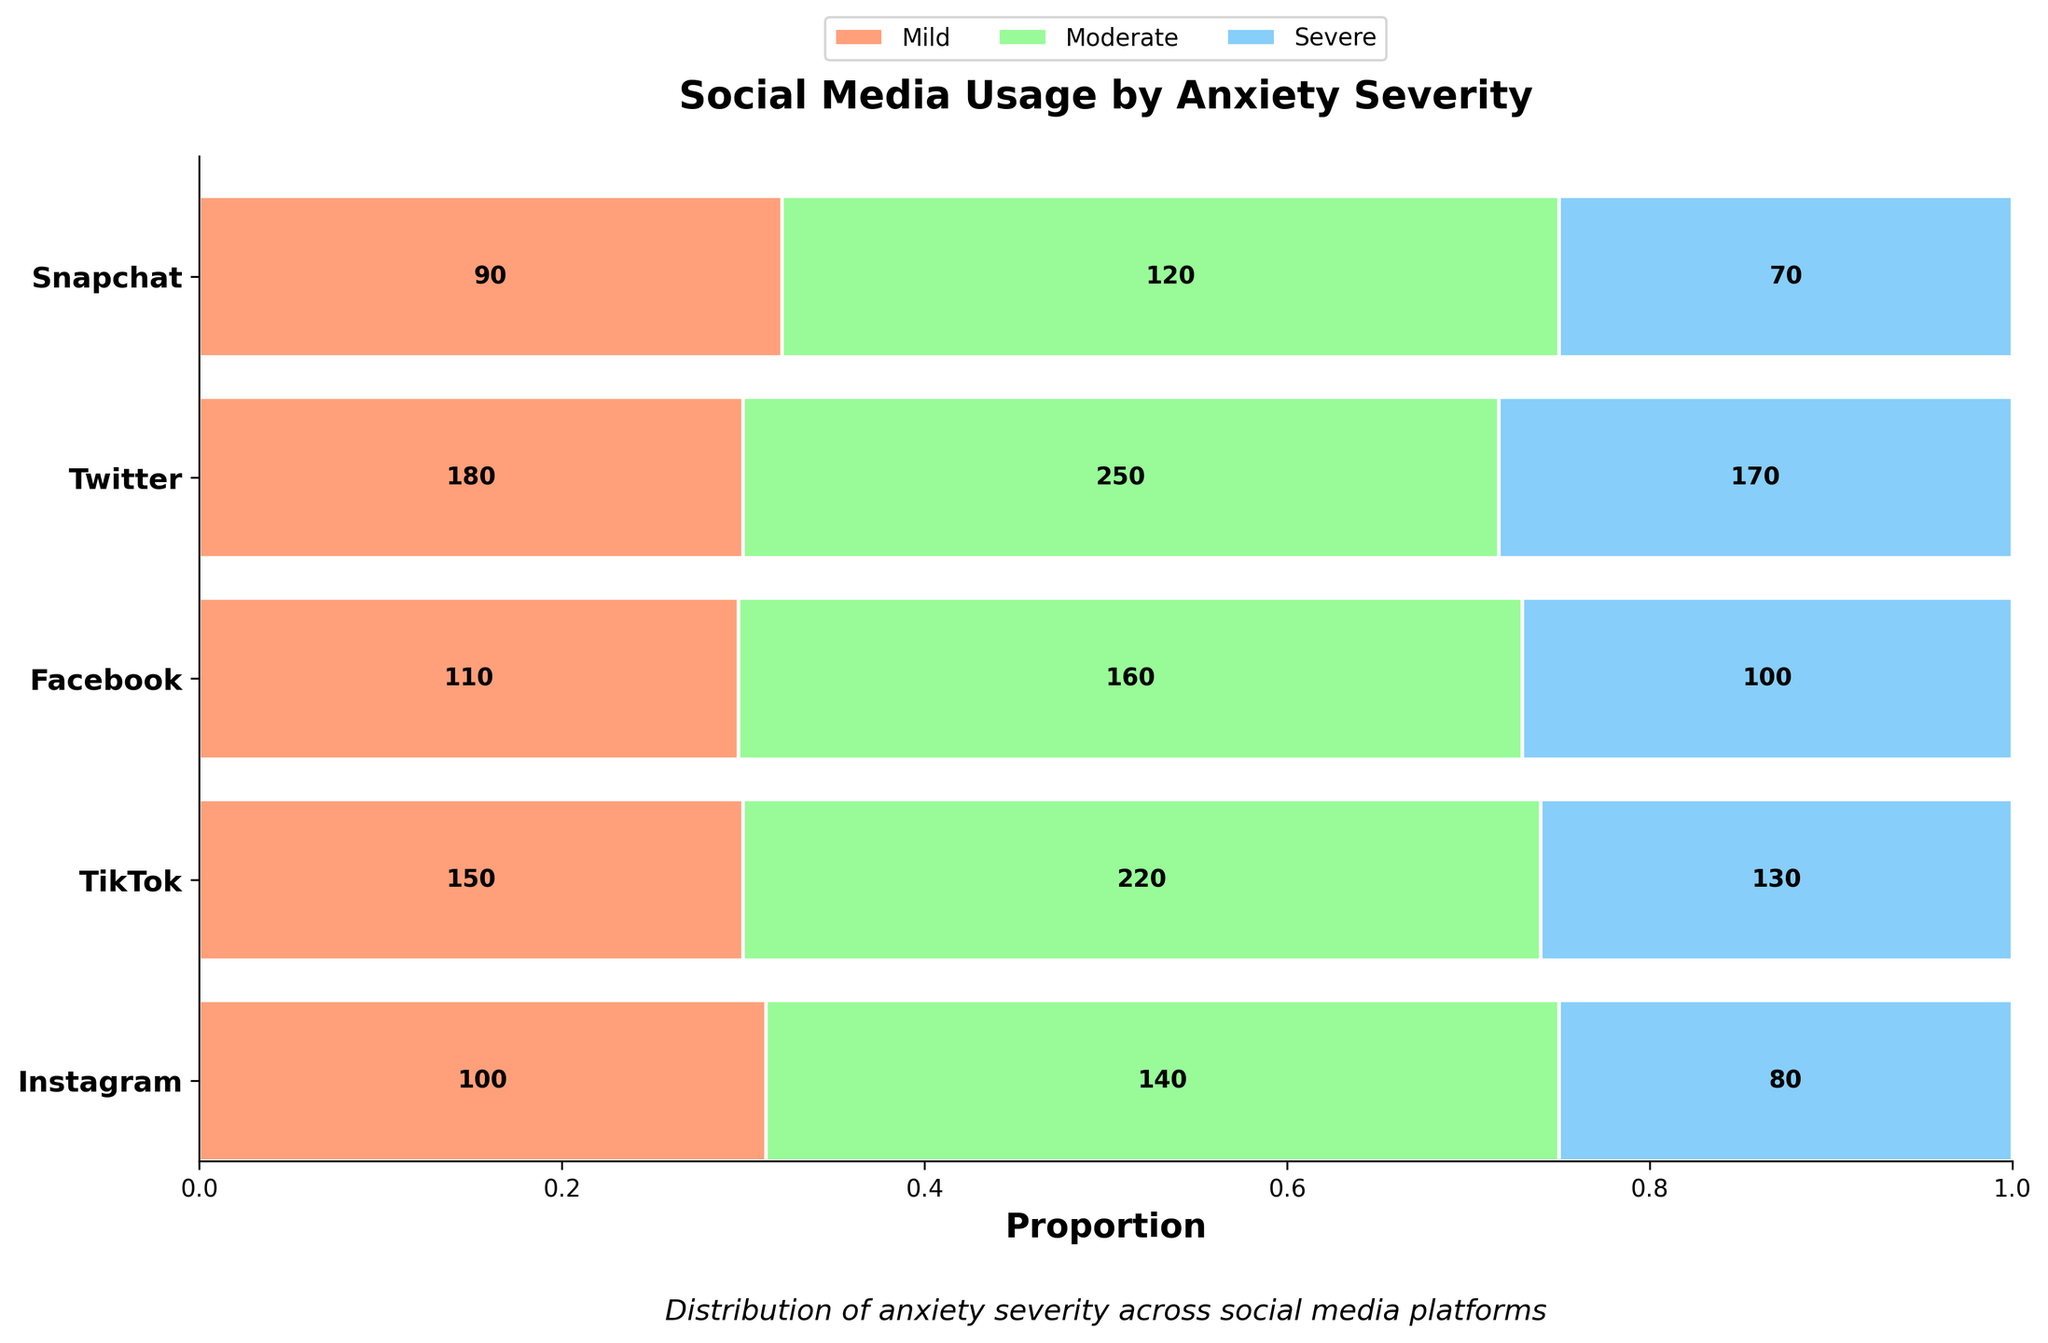Which platform has the highest count for severe anxiety cases? To determine this, look at the sections labeled "Severe" and compare the heights of the bars for each platform. The platform with the highest segment among these is TikTok with 170 cases.
Answer: TikTok What is the total number of young adults with moderate anxiety using Snapchat and Facebook combined? To find this, add the counts for moderate anxiety for Snapchat and Facebook. Snapchat has 160 cases, and Facebook has 140. So, the total is 160 + 140 = 300.
Answer: 300 Which platform has the smallest proportion of mild anxiety cases? To find the platform with the smallest proportion of mild anxiety, compare the widths of the mild anxiety segments across all platforms. Twitter has the narrowest segment for mild anxiety.
Answer: Twitter How does the number of moderate anxiety cases compare between Instagram and TikTok? Compare the counts of moderate anxiety cases for Instagram (220) and TikTok (250). TikTok has more cases (250 > 220).
Answer: TikTok has more Rank the platforms from highest to lowest based on severe anxiety cases. Rank the platforms by their counts for severe anxiety: TikTok (170), Instagram (130), Snapchat (100), Facebook (80), and Twitter (70). This ranking is based on the heights of the "Severe" segments.
Answer: TikTok, Instagram, Snapchat, Facebook, Twitter What proportion of Facebook users have moderate anxiety? Calculate the proportion by dividing the count of moderate anxiety cases on Facebook by the total number of Facebook users. The counts are: Mild (100), Moderate (140), Severe (80), totaling 320. The proportion is 140/320 = 0.4375.
Answer: 0.4375 Which social media platform has the most balanced distribution of anxiety severities? Assess the relative proportions of mild, moderate, and severe categories for each platform. Snapchat appears to have a more evenly distributed set of counts among the three categories, compared to other platforms.
Answer: Snapchat How many more severe anxiety cases are there on TikTok compared to Instagram? Subtract the severe anxiety cases of Instagram from TikTok. TikTok has 170 cases, Instagram has 130, so the difference is 170 - 130 = 40.
Answer: 40 Which social media platform has the highest proportion of moderate anxiety cases out of total severe and moderate cases combined? Calculate for each platform the ratio of moderate cases to the combined moderate and severe cases. Instagram: 220/(220+130) = 0.628. TikTok: 250/(250+170) = 0.595. Facebook: 140/(140+80) = 0.636. Twitter: 120/(120+70) = 0.63. Snapchat: 160/(160+100) = 0.615. Facebook has the highest proportion.
Answer: Facebook 